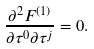<formula> <loc_0><loc_0><loc_500><loc_500>\frac { \partial ^ { 2 } F ^ { ( 1 ) } } { \partial \tau ^ { 0 } \partial \tau ^ { j } } = 0 .</formula> 